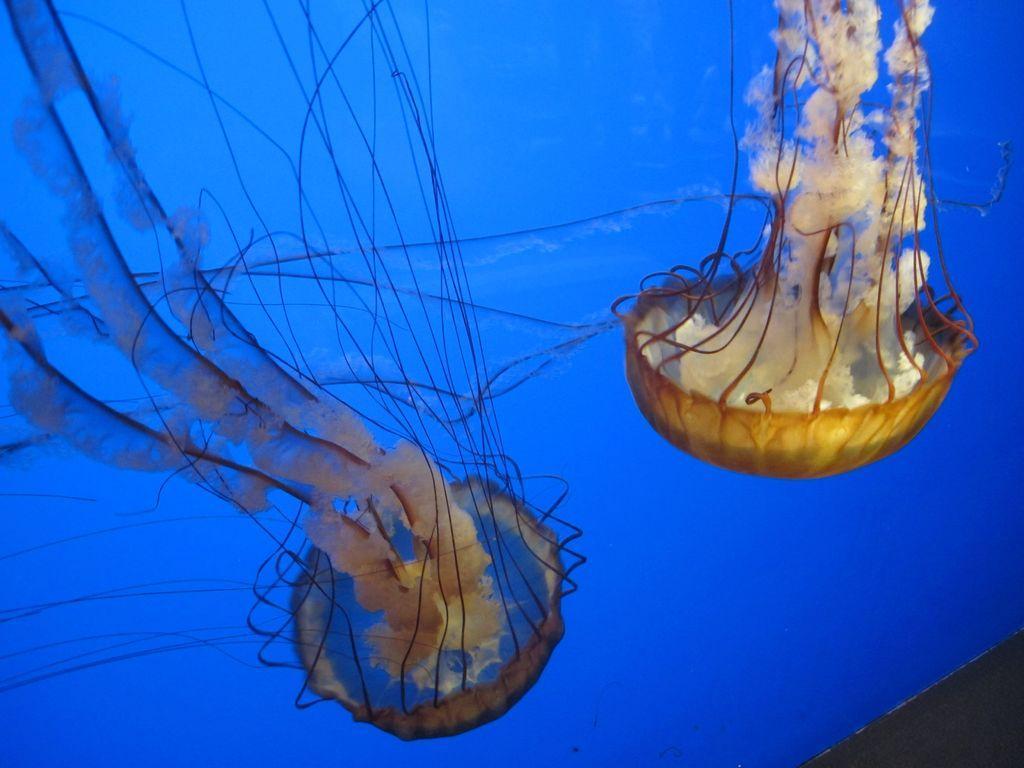How would you summarize this image in a sentence or two? In this image we can see two jellyfishes in the water. 